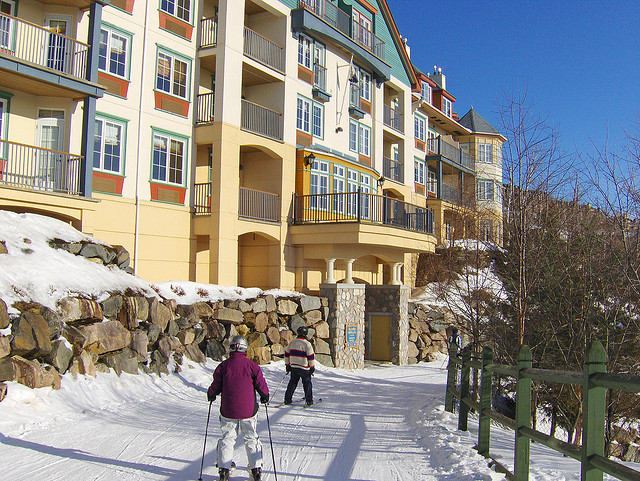Can you describe the environment around the skiers? Certainly! The skiers are surrounded by a wintery scene, with snow covering the ground and the side of the building. There's a clear blue sky overhead, and it seems to be a bright, sunny day, offering good visibility and pleasant conditions for skiing. Are there any safety concerns one should be aware of while skiing in such an environment? When skiing in such conditions, it's important to be mindful of the risk of cold exposure and to dress appropriately. Additionally, skiers should stay on designated paths to avoid any unexpected terrain or obstacles that could cause injury. 